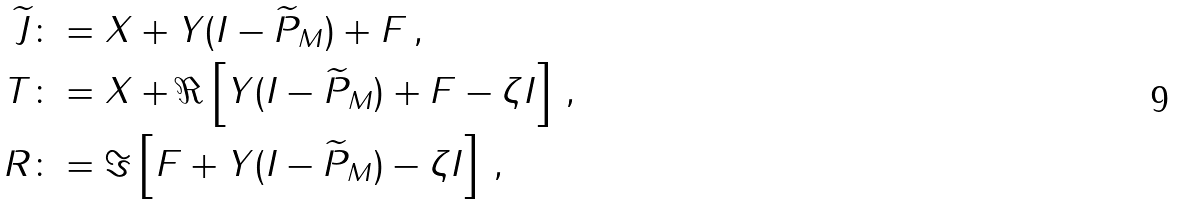Convert formula to latex. <formula><loc_0><loc_0><loc_500><loc_500>\widetilde { J } & \colon = X + Y ( I - \widetilde { P } _ { M } ) + F \, , \\ T & \colon = X + \Re \left [ Y ( I - \widetilde { P } _ { M } ) + F - \zeta I \right ] \, , \\ R & \colon = \Im \left [ F + Y ( I - \widetilde { P } _ { M } ) - \zeta I \right ] \, ,</formula> 